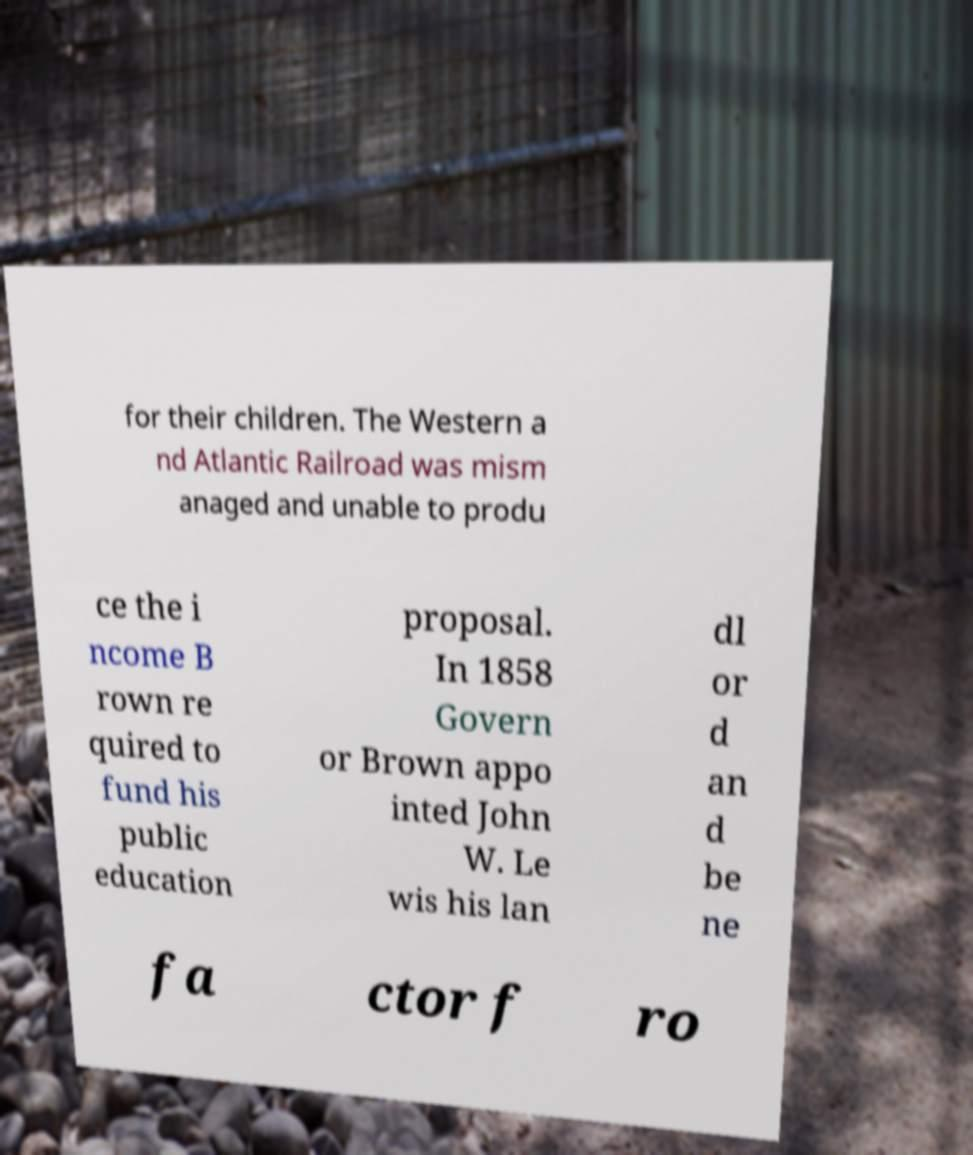I need the written content from this picture converted into text. Can you do that? for their children. The Western a nd Atlantic Railroad was mism anaged and unable to produ ce the i ncome B rown re quired to fund his public education proposal. In 1858 Govern or Brown appo inted John W. Le wis his lan dl or d an d be ne fa ctor f ro 